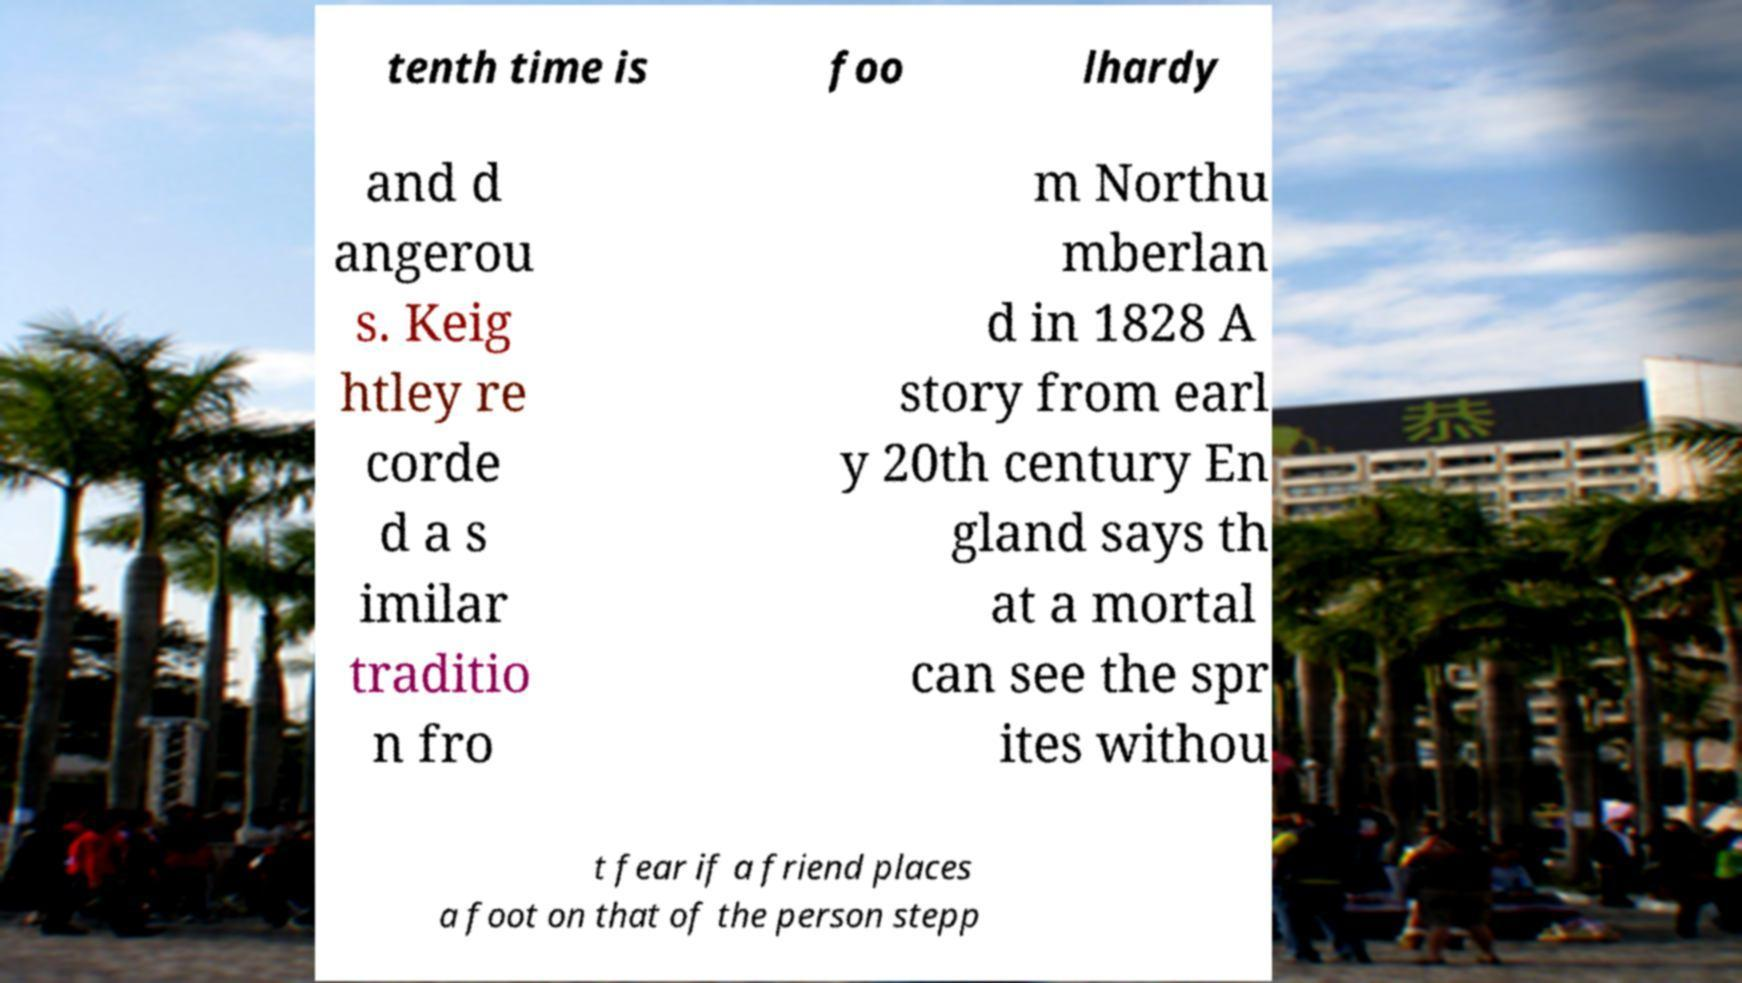There's text embedded in this image that I need extracted. Can you transcribe it verbatim? tenth time is foo lhardy and d angerou s. Keig htley re corde d a s imilar traditio n fro m Northu mberlan d in 1828 A story from earl y 20th century En gland says th at a mortal can see the spr ites withou t fear if a friend places a foot on that of the person stepp 